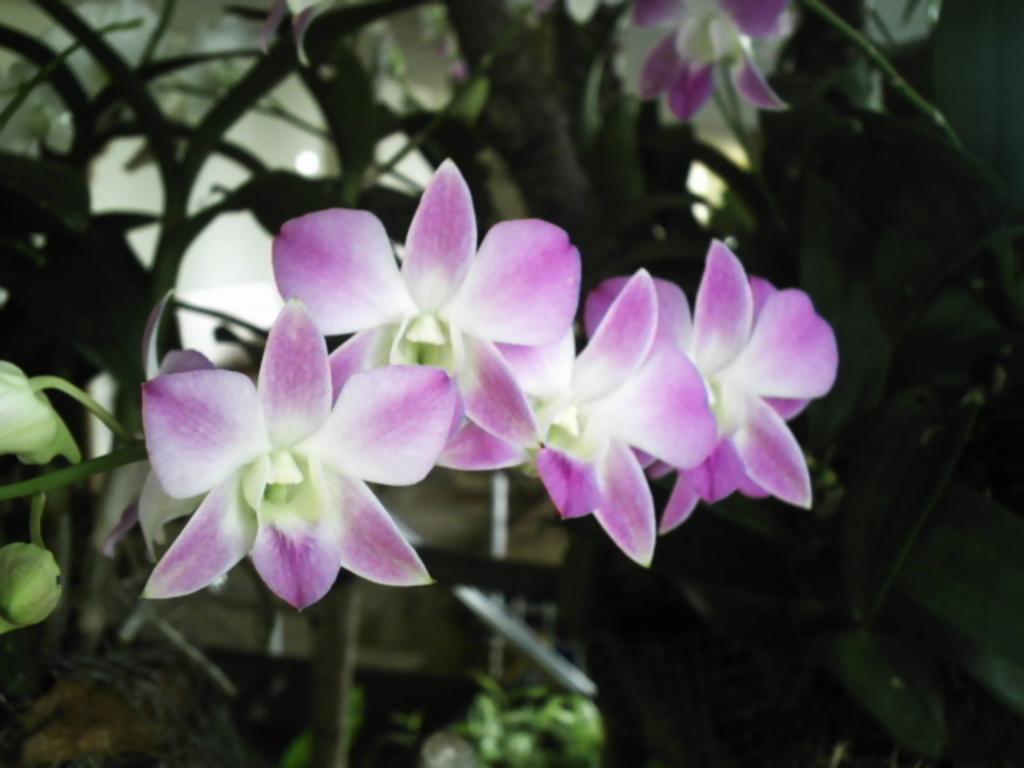Could you give a brief overview of what you see in this image? This image is taken outdoors. In this image there are a few plants with leaves, stems and flowers. Those flowers are lilac in color. 